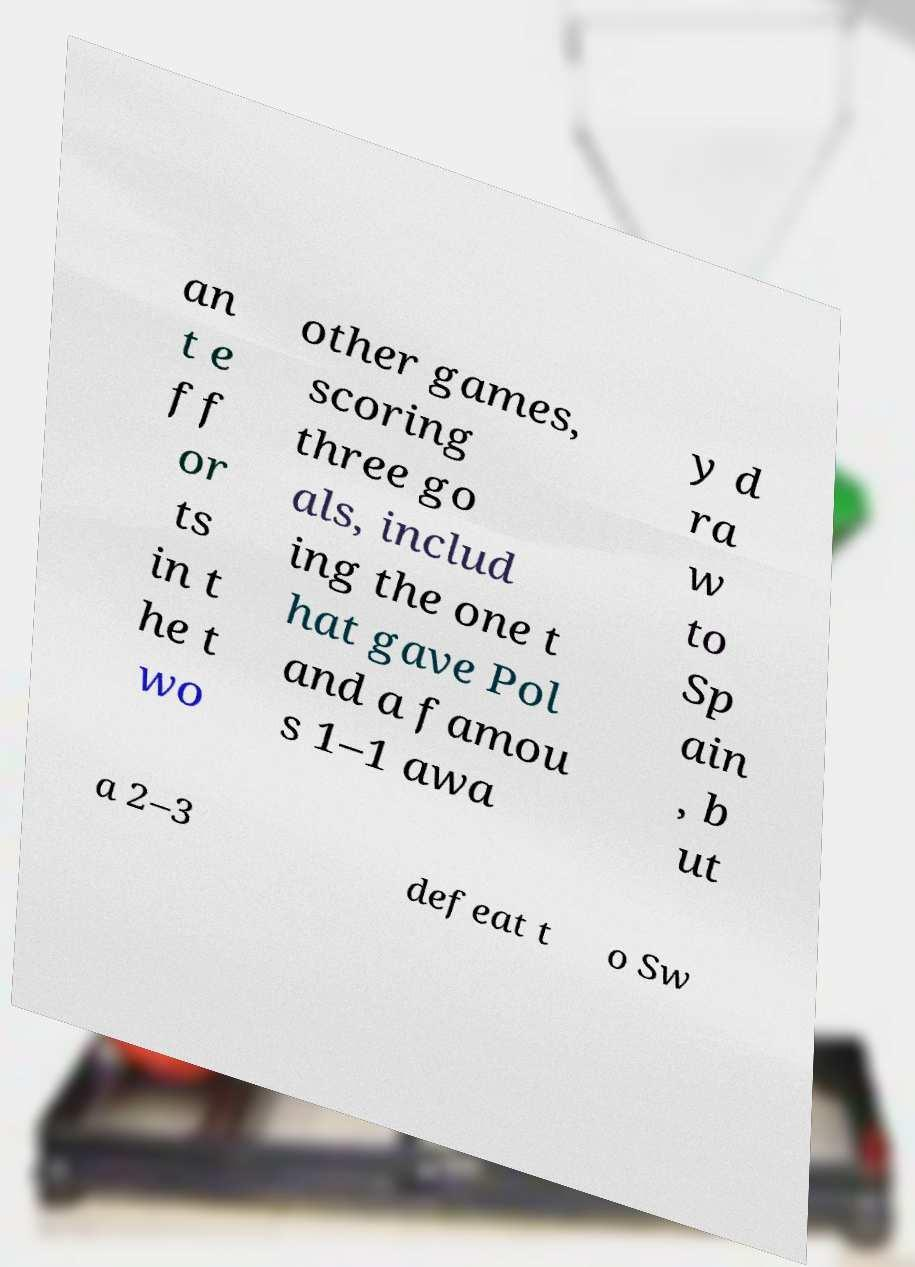I need the written content from this picture converted into text. Can you do that? an t e ff or ts in t he t wo other games, scoring three go als, includ ing the one t hat gave Pol and a famou s 1–1 awa y d ra w to Sp ain , b ut a 2–3 defeat t o Sw 